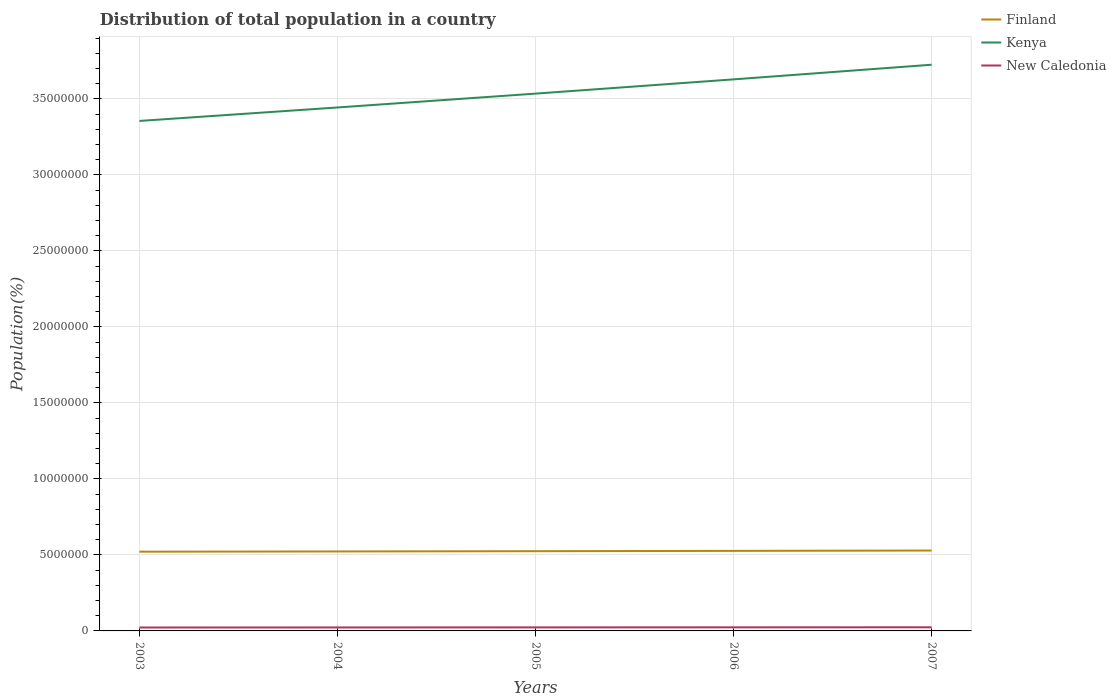Across all years, what is the maximum population of in Finland?
Ensure brevity in your answer.  5.21e+06. In which year was the population of in New Caledonia maximum?
Keep it short and to the point. 2003. What is the total population of in Finland in the graph?
Your response must be concise. -1.52e+04. What is the difference between the highest and the second highest population of in Finland?
Offer a terse response. 7.57e+04. Is the population of in Finland strictly greater than the population of in Kenya over the years?
Offer a terse response. Yes. How many lines are there?
Offer a very short reply. 3. How many years are there in the graph?
Give a very brief answer. 5. What is the difference between two consecutive major ticks on the Y-axis?
Offer a terse response. 5.00e+06. Are the values on the major ticks of Y-axis written in scientific E-notation?
Provide a succinct answer. No. Does the graph contain any zero values?
Your answer should be very brief. No. Where does the legend appear in the graph?
Give a very brief answer. Top right. What is the title of the graph?
Give a very brief answer. Distribution of total population in a country. Does "Arab World" appear as one of the legend labels in the graph?
Ensure brevity in your answer.  No. What is the label or title of the X-axis?
Provide a short and direct response. Years. What is the label or title of the Y-axis?
Make the answer very short. Population(%). What is the Population(%) of Finland in 2003?
Provide a short and direct response. 5.21e+06. What is the Population(%) of Kenya in 2003?
Your response must be concise. 3.36e+07. What is the Population(%) of New Caledonia in 2003?
Make the answer very short. 2.25e+05. What is the Population(%) of Finland in 2004?
Make the answer very short. 5.23e+06. What is the Population(%) of Kenya in 2004?
Provide a succinct answer. 3.44e+07. What is the Population(%) in New Caledonia in 2004?
Your answer should be very brief. 2.28e+05. What is the Population(%) in Finland in 2005?
Give a very brief answer. 5.25e+06. What is the Population(%) in Kenya in 2005?
Make the answer very short. 3.53e+07. What is the Population(%) in New Caledonia in 2005?
Give a very brief answer. 2.32e+05. What is the Population(%) of Finland in 2006?
Your answer should be very brief. 5.27e+06. What is the Population(%) in Kenya in 2006?
Provide a short and direct response. 3.63e+07. What is the Population(%) in New Caledonia in 2006?
Give a very brief answer. 2.35e+05. What is the Population(%) of Finland in 2007?
Offer a terse response. 5.29e+06. What is the Population(%) of Kenya in 2007?
Your response must be concise. 3.73e+07. What is the Population(%) of New Caledonia in 2007?
Offer a very short reply. 2.39e+05. Across all years, what is the maximum Population(%) of Finland?
Provide a succinct answer. 5.29e+06. Across all years, what is the maximum Population(%) of Kenya?
Keep it short and to the point. 3.73e+07. Across all years, what is the maximum Population(%) in New Caledonia?
Offer a very short reply. 2.39e+05. Across all years, what is the minimum Population(%) in Finland?
Offer a very short reply. 5.21e+06. Across all years, what is the minimum Population(%) in Kenya?
Offer a very short reply. 3.36e+07. Across all years, what is the minimum Population(%) in New Caledonia?
Provide a short and direct response. 2.25e+05. What is the total Population(%) in Finland in the graph?
Keep it short and to the point. 2.62e+07. What is the total Population(%) in Kenya in the graph?
Give a very brief answer. 1.77e+08. What is the total Population(%) of New Caledonia in the graph?
Ensure brevity in your answer.  1.16e+06. What is the difference between the Population(%) of Finland in 2003 and that in 2004?
Ensure brevity in your answer.  -1.52e+04. What is the difference between the Population(%) of Kenya in 2003 and that in 2004?
Keep it short and to the point. -8.86e+05. What is the difference between the Population(%) in New Caledonia in 2003 and that in 2004?
Your response must be concise. -3429. What is the difference between the Population(%) of Finland in 2003 and that in 2005?
Your answer should be compact. -3.31e+04. What is the difference between the Population(%) in Kenya in 2003 and that in 2005?
Make the answer very short. -1.80e+06. What is the difference between the Population(%) of New Caledonia in 2003 and that in 2005?
Your answer should be very brief. -6911. What is the difference between the Population(%) in Finland in 2003 and that in 2006?
Provide a succinct answer. -5.33e+04. What is the difference between the Population(%) of Kenya in 2003 and that in 2006?
Make the answer very short. -2.73e+06. What is the difference between the Population(%) in New Caledonia in 2003 and that in 2006?
Give a very brief answer. -1.04e+04. What is the difference between the Population(%) in Finland in 2003 and that in 2007?
Offer a very short reply. -7.57e+04. What is the difference between the Population(%) of Kenya in 2003 and that in 2007?
Make the answer very short. -3.70e+06. What is the difference between the Population(%) in New Caledonia in 2003 and that in 2007?
Provide a succinct answer. -1.40e+04. What is the difference between the Population(%) in Finland in 2004 and that in 2005?
Your answer should be very brief. -1.79e+04. What is the difference between the Population(%) of Kenya in 2004 and that in 2005?
Offer a terse response. -9.12e+05. What is the difference between the Population(%) of New Caledonia in 2004 and that in 2005?
Make the answer very short. -3482. What is the difference between the Population(%) of Finland in 2004 and that in 2006?
Ensure brevity in your answer.  -3.81e+04. What is the difference between the Population(%) of Kenya in 2004 and that in 2006?
Provide a succinct answer. -1.85e+06. What is the difference between the Population(%) of New Caledonia in 2004 and that in 2006?
Make the answer very short. -7017. What is the difference between the Population(%) of Finland in 2004 and that in 2007?
Make the answer very short. -6.05e+04. What is the difference between the Population(%) in Kenya in 2004 and that in 2007?
Keep it short and to the point. -2.81e+06. What is the difference between the Population(%) of New Caledonia in 2004 and that in 2007?
Offer a very short reply. -1.06e+04. What is the difference between the Population(%) of Finland in 2005 and that in 2006?
Your answer should be compact. -2.02e+04. What is the difference between the Population(%) in Kenya in 2005 and that in 2006?
Make the answer very short. -9.37e+05. What is the difference between the Population(%) of New Caledonia in 2005 and that in 2006?
Keep it short and to the point. -3535. What is the difference between the Population(%) of Finland in 2005 and that in 2007?
Ensure brevity in your answer.  -4.26e+04. What is the difference between the Population(%) in Kenya in 2005 and that in 2007?
Keep it short and to the point. -1.90e+06. What is the difference between the Population(%) of New Caledonia in 2005 and that in 2007?
Make the answer very short. -7123. What is the difference between the Population(%) in Finland in 2006 and that in 2007?
Provide a short and direct response. -2.25e+04. What is the difference between the Population(%) of Kenya in 2006 and that in 2007?
Ensure brevity in your answer.  -9.65e+05. What is the difference between the Population(%) of New Caledonia in 2006 and that in 2007?
Give a very brief answer. -3588. What is the difference between the Population(%) of Finland in 2003 and the Population(%) of Kenya in 2004?
Keep it short and to the point. -2.92e+07. What is the difference between the Population(%) of Finland in 2003 and the Population(%) of New Caledonia in 2004?
Ensure brevity in your answer.  4.98e+06. What is the difference between the Population(%) in Kenya in 2003 and the Population(%) in New Caledonia in 2004?
Offer a very short reply. 3.33e+07. What is the difference between the Population(%) in Finland in 2003 and the Population(%) in Kenya in 2005?
Your response must be concise. -3.01e+07. What is the difference between the Population(%) of Finland in 2003 and the Population(%) of New Caledonia in 2005?
Provide a short and direct response. 4.98e+06. What is the difference between the Population(%) of Kenya in 2003 and the Population(%) of New Caledonia in 2005?
Give a very brief answer. 3.33e+07. What is the difference between the Population(%) of Finland in 2003 and the Population(%) of Kenya in 2006?
Keep it short and to the point. -3.11e+07. What is the difference between the Population(%) in Finland in 2003 and the Population(%) in New Caledonia in 2006?
Ensure brevity in your answer.  4.98e+06. What is the difference between the Population(%) of Kenya in 2003 and the Population(%) of New Caledonia in 2006?
Your response must be concise. 3.33e+07. What is the difference between the Population(%) in Finland in 2003 and the Population(%) in Kenya in 2007?
Provide a succinct answer. -3.20e+07. What is the difference between the Population(%) of Finland in 2003 and the Population(%) of New Caledonia in 2007?
Keep it short and to the point. 4.97e+06. What is the difference between the Population(%) in Kenya in 2003 and the Population(%) in New Caledonia in 2007?
Offer a very short reply. 3.33e+07. What is the difference between the Population(%) in Finland in 2004 and the Population(%) in Kenya in 2005?
Ensure brevity in your answer.  -3.01e+07. What is the difference between the Population(%) in Finland in 2004 and the Population(%) in New Caledonia in 2005?
Make the answer very short. 5.00e+06. What is the difference between the Population(%) of Kenya in 2004 and the Population(%) of New Caledonia in 2005?
Keep it short and to the point. 3.42e+07. What is the difference between the Population(%) of Finland in 2004 and the Population(%) of Kenya in 2006?
Ensure brevity in your answer.  -3.11e+07. What is the difference between the Population(%) in Finland in 2004 and the Population(%) in New Caledonia in 2006?
Your answer should be compact. 4.99e+06. What is the difference between the Population(%) in Kenya in 2004 and the Population(%) in New Caledonia in 2006?
Keep it short and to the point. 3.42e+07. What is the difference between the Population(%) of Finland in 2004 and the Population(%) of Kenya in 2007?
Offer a terse response. -3.20e+07. What is the difference between the Population(%) of Finland in 2004 and the Population(%) of New Caledonia in 2007?
Your answer should be very brief. 4.99e+06. What is the difference between the Population(%) of Kenya in 2004 and the Population(%) of New Caledonia in 2007?
Provide a succinct answer. 3.42e+07. What is the difference between the Population(%) in Finland in 2005 and the Population(%) in Kenya in 2006?
Your answer should be compact. -3.10e+07. What is the difference between the Population(%) in Finland in 2005 and the Population(%) in New Caledonia in 2006?
Offer a terse response. 5.01e+06. What is the difference between the Population(%) of Kenya in 2005 and the Population(%) of New Caledonia in 2006?
Provide a succinct answer. 3.51e+07. What is the difference between the Population(%) in Finland in 2005 and the Population(%) in Kenya in 2007?
Provide a succinct answer. -3.20e+07. What is the difference between the Population(%) of Finland in 2005 and the Population(%) of New Caledonia in 2007?
Give a very brief answer. 5.01e+06. What is the difference between the Population(%) in Kenya in 2005 and the Population(%) in New Caledonia in 2007?
Your answer should be very brief. 3.51e+07. What is the difference between the Population(%) of Finland in 2006 and the Population(%) of Kenya in 2007?
Give a very brief answer. -3.20e+07. What is the difference between the Population(%) in Finland in 2006 and the Population(%) in New Caledonia in 2007?
Offer a terse response. 5.03e+06. What is the difference between the Population(%) in Kenya in 2006 and the Population(%) in New Caledonia in 2007?
Provide a succinct answer. 3.60e+07. What is the average Population(%) in Finland per year?
Your answer should be compact. 5.25e+06. What is the average Population(%) of Kenya per year?
Provide a short and direct response. 3.54e+07. What is the average Population(%) of New Caledonia per year?
Offer a very short reply. 2.32e+05. In the year 2003, what is the difference between the Population(%) of Finland and Population(%) of Kenya?
Make the answer very short. -2.83e+07. In the year 2003, what is the difference between the Population(%) in Finland and Population(%) in New Caledonia?
Your answer should be compact. 4.99e+06. In the year 2003, what is the difference between the Population(%) of Kenya and Population(%) of New Caledonia?
Ensure brevity in your answer.  3.33e+07. In the year 2004, what is the difference between the Population(%) of Finland and Population(%) of Kenya?
Keep it short and to the point. -2.92e+07. In the year 2004, what is the difference between the Population(%) in Finland and Population(%) in New Caledonia?
Give a very brief answer. 5.00e+06. In the year 2004, what is the difference between the Population(%) of Kenya and Population(%) of New Caledonia?
Your answer should be very brief. 3.42e+07. In the year 2005, what is the difference between the Population(%) of Finland and Population(%) of Kenya?
Offer a very short reply. -3.01e+07. In the year 2005, what is the difference between the Population(%) of Finland and Population(%) of New Caledonia?
Keep it short and to the point. 5.01e+06. In the year 2005, what is the difference between the Population(%) in Kenya and Population(%) in New Caledonia?
Your answer should be compact. 3.51e+07. In the year 2006, what is the difference between the Population(%) of Finland and Population(%) of Kenya?
Your response must be concise. -3.10e+07. In the year 2006, what is the difference between the Population(%) in Finland and Population(%) in New Caledonia?
Your answer should be compact. 5.03e+06. In the year 2006, what is the difference between the Population(%) of Kenya and Population(%) of New Caledonia?
Ensure brevity in your answer.  3.61e+07. In the year 2007, what is the difference between the Population(%) of Finland and Population(%) of Kenya?
Ensure brevity in your answer.  -3.20e+07. In the year 2007, what is the difference between the Population(%) in Finland and Population(%) in New Caledonia?
Offer a very short reply. 5.05e+06. In the year 2007, what is the difference between the Population(%) in Kenya and Population(%) in New Caledonia?
Your response must be concise. 3.70e+07. What is the ratio of the Population(%) in Kenya in 2003 to that in 2004?
Ensure brevity in your answer.  0.97. What is the ratio of the Population(%) of Finland in 2003 to that in 2005?
Offer a terse response. 0.99. What is the ratio of the Population(%) in Kenya in 2003 to that in 2005?
Your answer should be compact. 0.95. What is the ratio of the Population(%) in New Caledonia in 2003 to that in 2005?
Offer a very short reply. 0.97. What is the ratio of the Population(%) in Kenya in 2003 to that in 2006?
Keep it short and to the point. 0.92. What is the ratio of the Population(%) in New Caledonia in 2003 to that in 2006?
Your answer should be very brief. 0.96. What is the ratio of the Population(%) of Finland in 2003 to that in 2007?
Make the answer very short. 0.99. What is the ratio of the Population(%) of Kenya in 2003 to that in 2007?
Your answer should be very brief. 0.9. What is the ratio of the Population(%) of New Caledonia in 2003 to that in 2007?
Provide a short and direct response. 0.94. What is the ratio of the Population(%) of Kenya in 2004 to that in 2005?
Provide a succinct answer. 0.97. What is the ratio of the Population(%) in New Caledonia in 2004 to that in 2005?
Make the answer very short. 0.98. What is the ratio of the Population(%) in Kenya in 2004 to that in 2006?
Ensure brevity in your answer.  0.95. What is the ratio of the Population(%) in New Caledonia in 2004 to that in 2006?
Your answer should be very brief. 0.97. What is the ratio of the Population(%) in Kenya in 2004 to that in 2007?
Provide a succinct answer. 0.92. What is the ratio of the Population(%) in New Caledonia in 2004 to that in 2007?
Give a very brief answer. 0.96. What is the ratio of the Population(%) in Finland in 2005 to that in 2006?
Your answer should be compact. 1. What is the ratio of the Population(%) of Kenya in 2005 to that in 2006?
Ensure brevity in your answer.  0.97. What is the ratio of the Population(%) in Finland in 2005 to that in 2007?
Provide a short and direct response. 0.99. What is the ratio of the Population(%) of Kenya in 2005 to that in 2007?
Ensure brevity in your answer.  0.95. What is the ratio of the Population(%) in New Caledonia in 2005 to that in 2007?
Your answer should be compact. 0.97. What is the ratio of the Population(%) in Kenya in 2006 to that in 2007?
Provide a succinct answer. 0.97. What is the ratio of the Population(%) in New Caledonia in 2006 to that in 2007?
Provide a short and direct response. 0.98. What is the difference between the highest and the second highest Population(%) of Finland?
Keep it short and to the point. 2.25e+04. What is the difference between the highest and the second highest Population(%) of Kenya?
Provide a short and direct response. 9.65e+05. What is the difference between the highest and the second highest Population(%) in New Caledonia?
Give a very brief answer. 3588. What is the difference between the highest and the lowest Population(%) of Finland?
Your answer should be compact. 7.57e+04. What is the difference between the highest and the lowest Population(%) of Kenya?
Provide a short and direct response. 3.70e+06. What is the difference between the highest and the lowest Population(%) in New Caledonia?
Keep it short and to the point. 1.40e+04. 